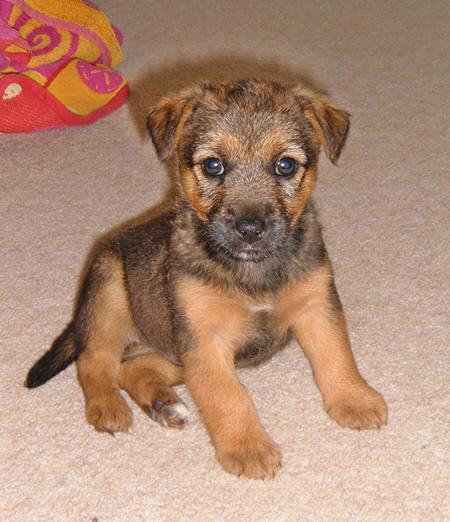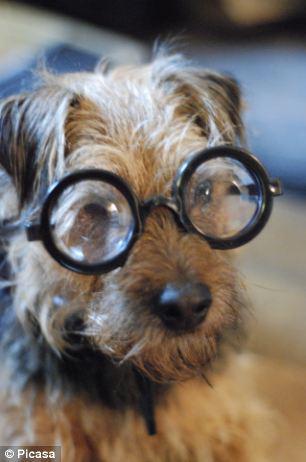The first image is the image on the left, the second image is the image on the right. For the images shown, is this caption "One dog is wearing a collar and has its mouth closed." true? Answer yes or no. No. The first image is the image on the left, the second image is the image on the right. Evaluate the accuracy of this statement regarding the images: "Left image shows a dog wearing a collar.". Is it true? Answer yes or no. No. 